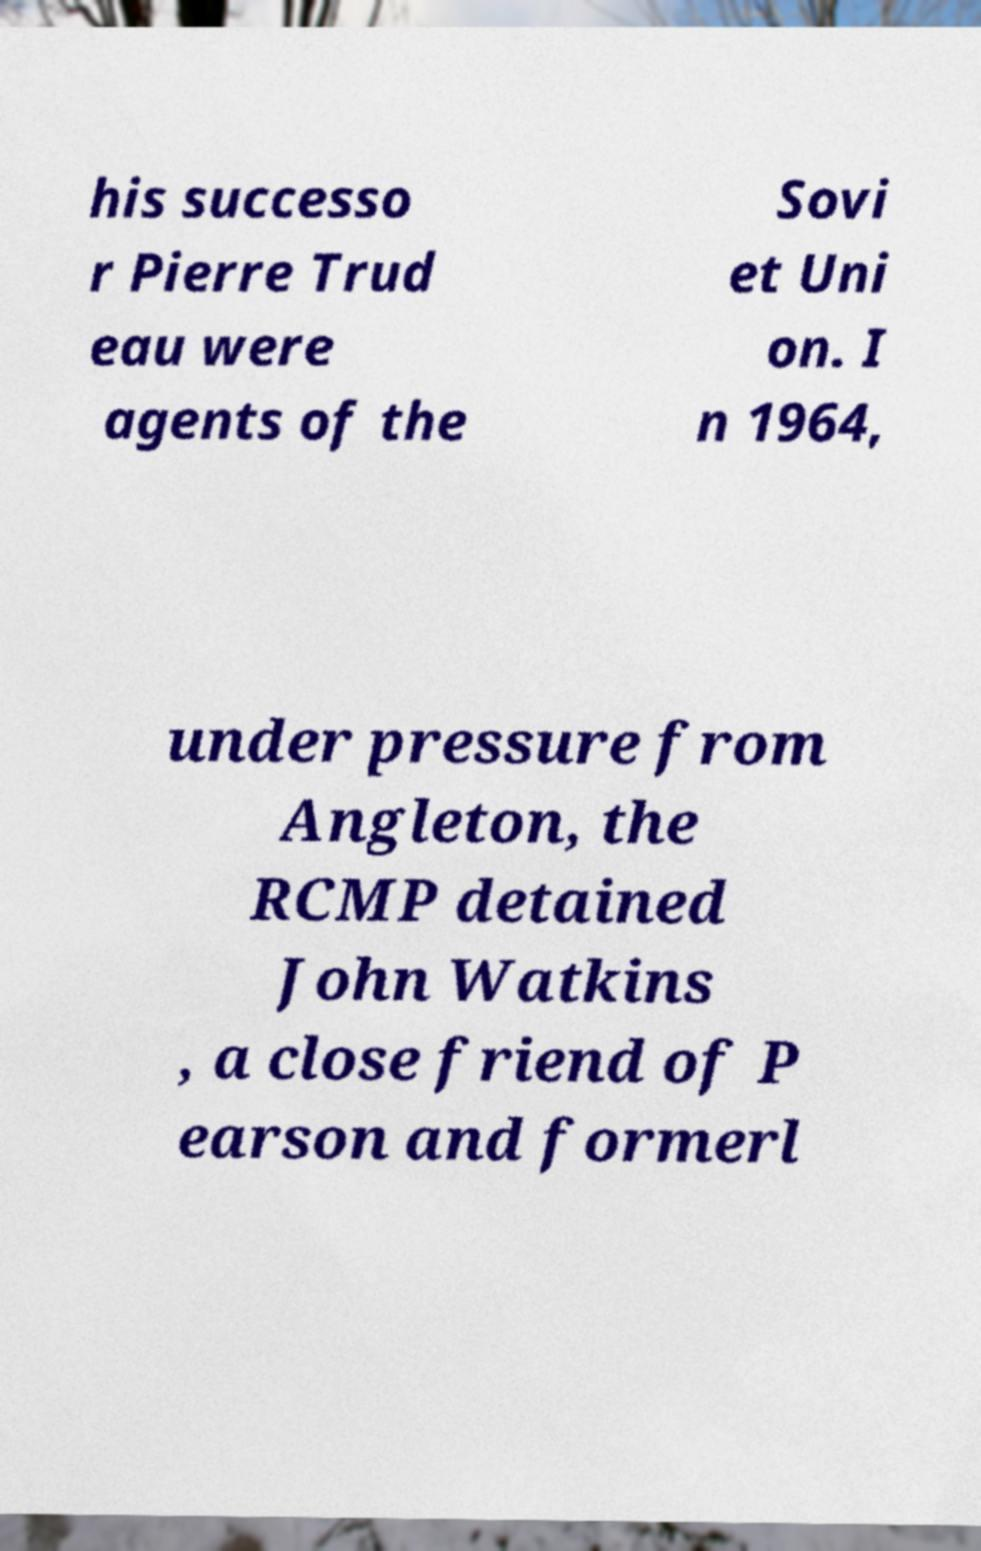Please read and relay the text visible in this image. What does it say? his successo r Pierre Trud eau were agents of the Sovi et Uni on. I n 1964, under pressure from Angleton, the RCMP detained John Watkins , a close friend of P earson and formerl 